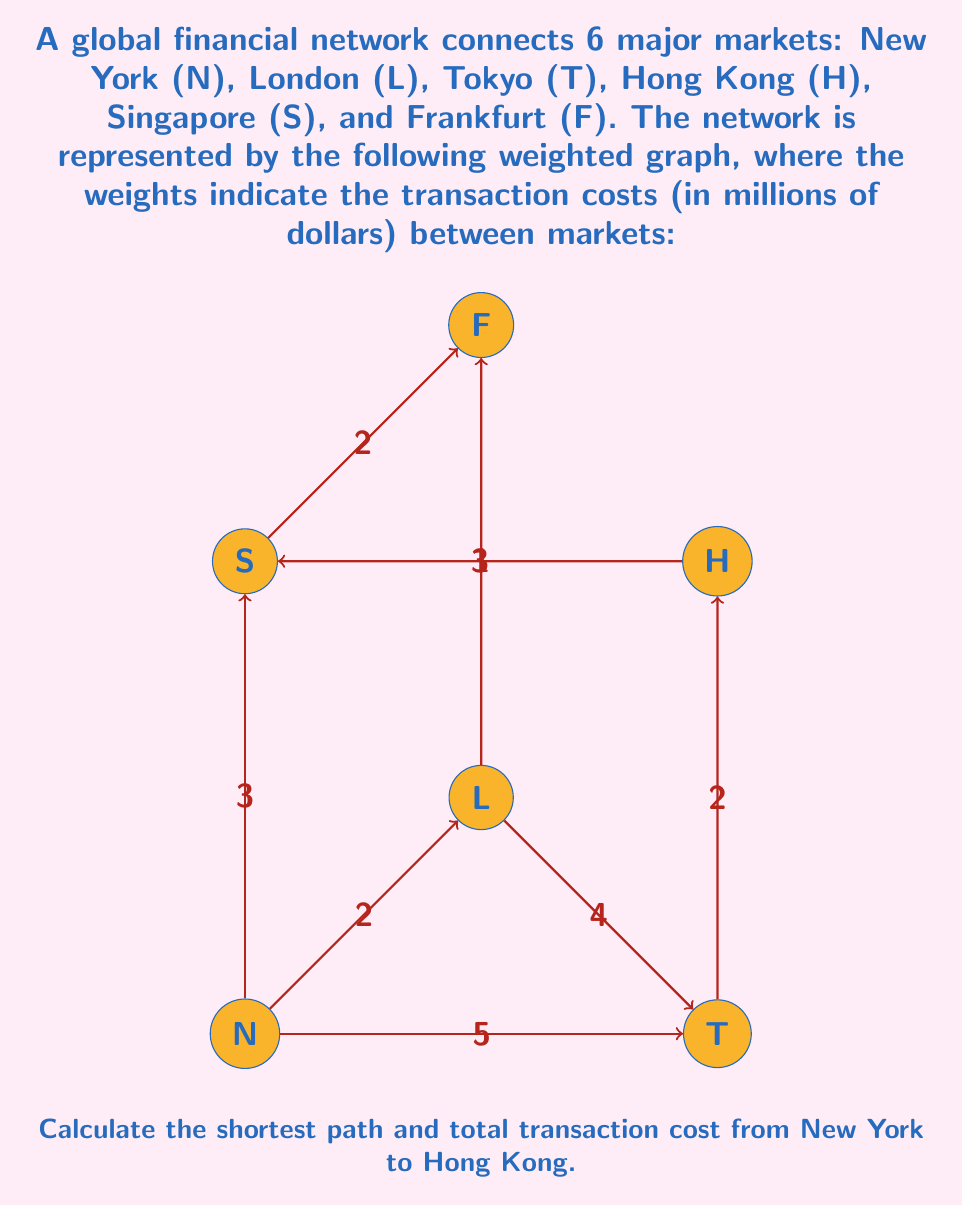Help me with this question. To solve this problem, we'll use Dijkstra's algorithm to find the shortest path from New York (N) to Hong Kong (H). Let's go through the steps:

1) Initialize:
   - Distance to N: 0
   - Distance to all other vertices: ∞ (infinity)
   - Set of unvisited nodes: {N, L, T, H, S, F}

2) From N:
   - Update distances: N(0), L(2), T(5), S(3), F(∞), H(∞)
   - Mark N as visited
   - Unvisited set: {L, T, H, S, F}

3) Choose L (smallest distance among unvisited):
   - Update distances through L: F(2+1=3)
   - Mark L as visited
   - Unvisited set: {T, H, S, F}

4) Choose S (smallest distance among unvisited):
   - Update distances through S: F(3+2=5)
   - Mark S as visited
   - Unvisited set: {T, H, F}

5) Choose F:
   - No updates (all connected nodes visited)
   - Mark F as visited
   - Unvisited set: {T, H}

6) Choose T:
   - Update distances: H(5+2=7)
   - Mark T as visited
   - Unvisited set: {H}

7) Choose H:
   - No updates
   - Mark H as visited
   - Algorithm complete

The shortest path from N to H is: N → T → H
The total transaction cost is: $5 + $2 = $7 million
Answer: N → T → H, $7 million 